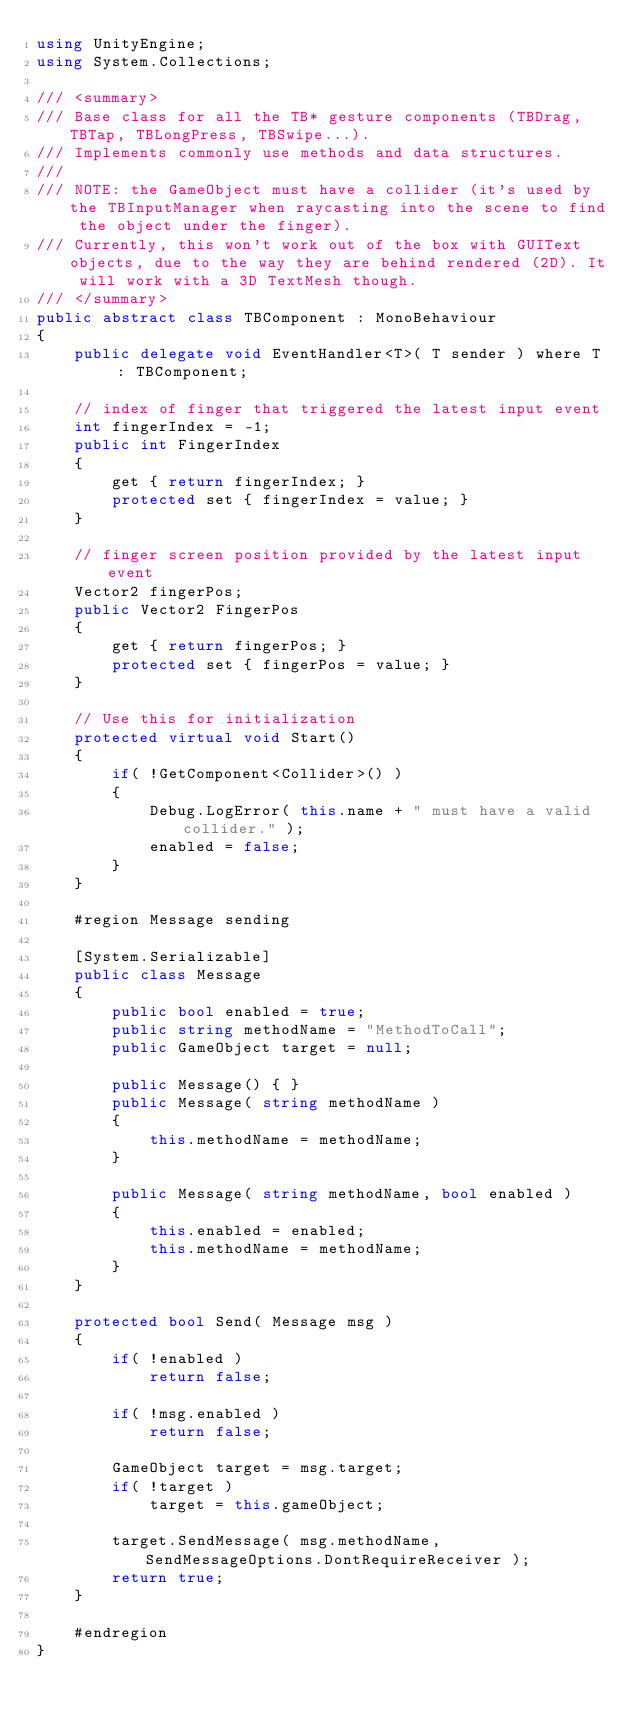Convert code to text. <code><loc_0><loc_0><loc_500><loc_500><_C#_>using UnityEngine;
using System.Collections;

/// <summary>
/// Base class for all the TB* gesture components (TBDrag, TBTap, TBLongPress, TBSwipe...).
/// Implements commonly use methods and data structures.
/// 
/// NOTE: the GameObject must have a collider (it's used by the TBInputManager when raycasting into the scene to find the object under the finger).
/// Currently, this won't work out of the box with GUIText objects, due to the way they are behind rendered (2D). It will work with a 3D TextMesh though.
/// </summary>
public abstract class TBComponent : MonoBehaviour
{
    public delegate void EventHandler<T>( T sender ) where T : TBComponent;

    // index of finger that triggered the latest input event
    int fingerIndex = -1;
    public int FingerIndex
    {
        get { return fingerIndex; }
        protected set { fingerIndex = value; }
    }

    // finger screen position provided by the latest input event
    Vector2 fingerPos;
    public Vector2 FingerPos
    {
        get { return fingerPos; }
        protected set { fingerPos = value; }
    }

    // Use this for initialization
    protected virtual void Start()
    {
        if( !GetComponent<Collider>() )
        {
            Debug.LogError( this.name + " must have a valid collider." );
            enabled = false;
        }
    }

    #region Message sending

    [System.Serializable]
    public class Message
    {
        public bool enabled = true;
        public string methodName = "MethodToCall";
        public GameObject target = null;

        public Message() { }
        public Message( string methodName )
        {
            this.methodName = methodName;
        }

        public Message( string methodName, bool enabled )
        {
            this.enabled = enabled;
            this.methodName = methodName;
        }
    }

    protected bool Send( Message msg )
    {
        if( !enabled )
            return false;

        if( !msg.enabled )
            return false;

        GameObject target = msg.target;
        if( !target )
            target = this.gameObject;

        target.SendMessage( msg.methodName, SendMessageOptions.DontRequireReceiver );
        return true;
    }

    #endregion
}
</code> 